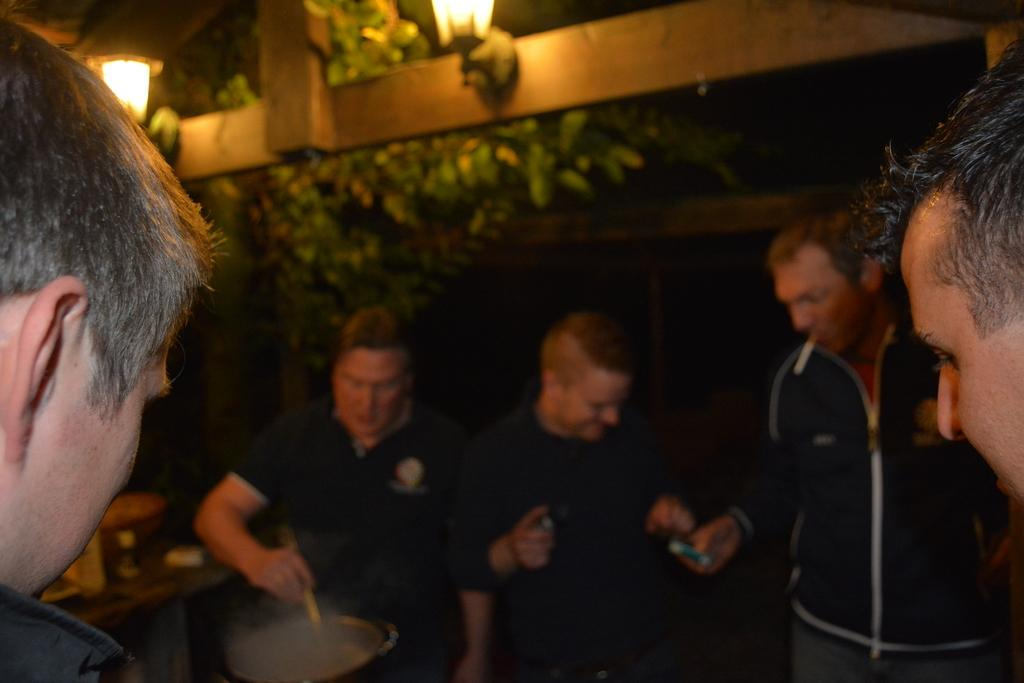What can be seen in the image? There are people standing in the image. What is above the people in the image? There is a ceiling in the image. What can be seen illuminating the area in the image? There are lights in the image. What type of vegetation is present in the image? There are plants in the image. What type of teaching is happening in the image? There is no teaching activity depicted in the image. Can you see an army in the image? There is no army present in the image. 